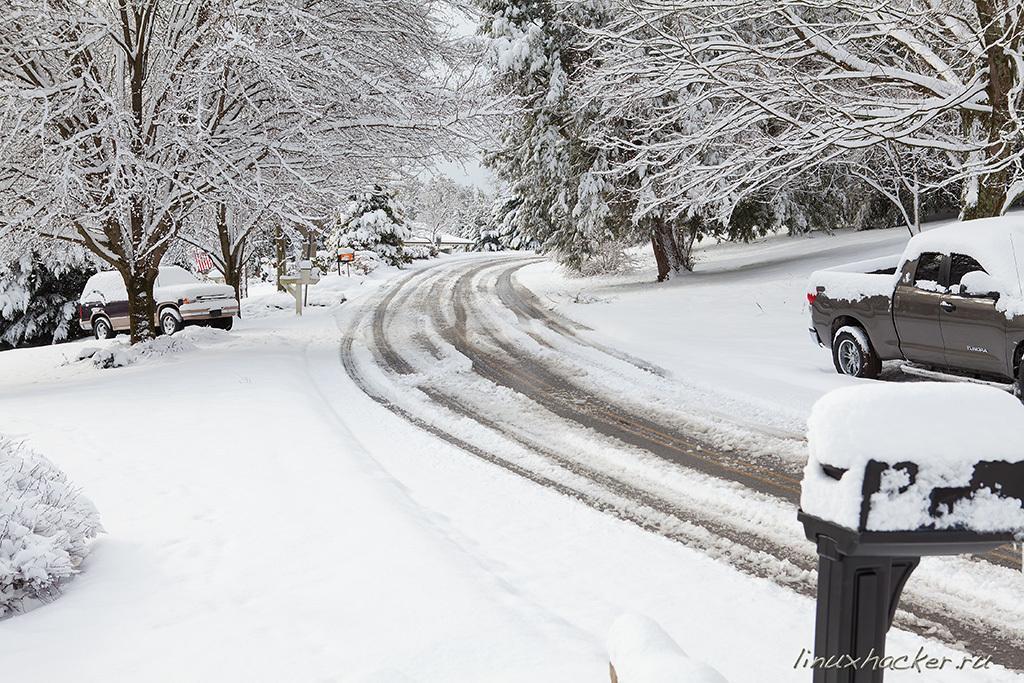Can you describe this image briefly? This image is clicked on the road. On the either sides of the road there is the ground. There are trees, plants and sign boards on the ground. There is snow on the trees and the ground. In the center there is the sky. In the bottom right there is text on the image. 